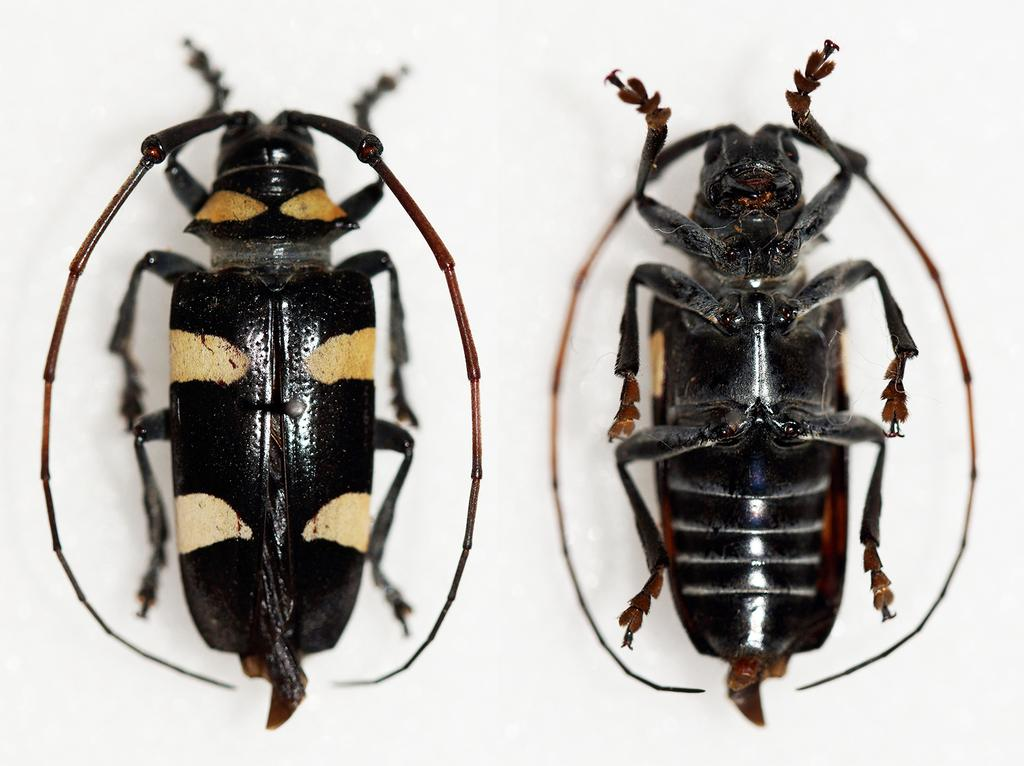What type of insects are in the image? There are two longhorn beetles in the image. What is the color of the surface on which the beetles are located? The beetles are on a white surface. What type of operation is being performed on the beetles in the image? There is no operation being performed on the beetles in the image; they are simply resting on a white surface. What type of pencil is visible in the image? There is no pencil present in the image. 